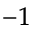<formula> <loc_0><loc_0><loc_500><loc_500>^ { - 1 }</formula> 